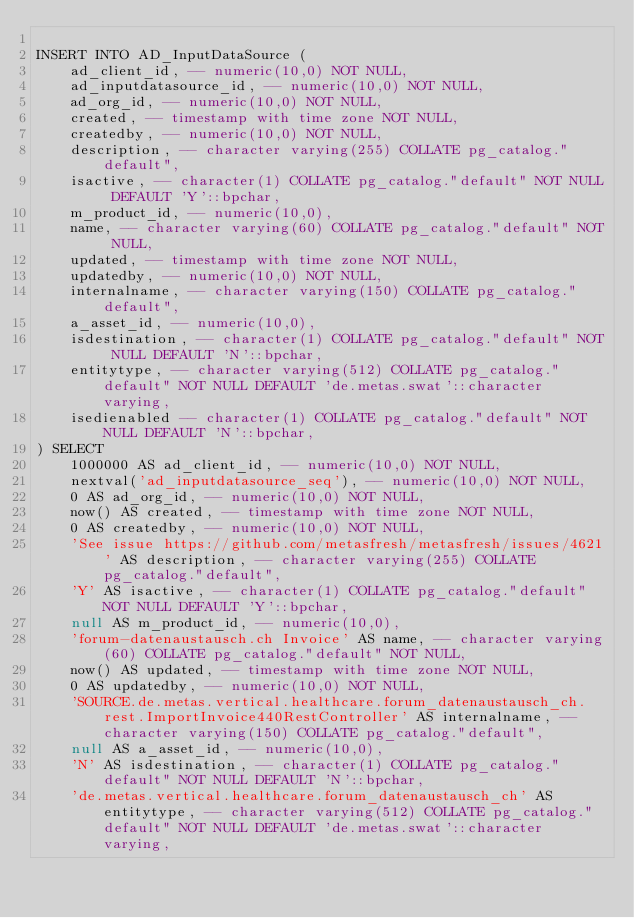Convert code to text. <code><loc_0><loc_0><loc_500><loc_500><_SQL_>
INSERT INTO AD_InputDataSource (
    ad_client_id, -- numeric(10,0) NOT NULL,
    ad_inputdatasource_id, -- numeric(10,0) NOT NULL,
    ad_org_id, -- numeric(10,0) NOT NULL,
    created, -- timestamp with time zone NOT NULL,
    createdby, -- numeric(10,0) NOT NULL,
    description, -- character varying(255) COLLATE pg_catalog."default",
    isactive, -- character(1) COLLATE pg_catalog."default" NOT NULL DEFAULT 'Y'::bpchar,
    m_product_id, -- numeric(10,0),
    name, -- character varying(60) COLLATE pg_catalog."default" NOT NULL,
    updated, -- timestamp with time zone NOT NULL,
    updatedby, -- numeric(10,0) NOT NULL,
    internalname, -- character varying(150) COLLATE pg_catalog."default",
    a_asset_id, -- numeric(10,0),
    isdestination, -- character(1) COLLATE pg_catalog."default" NOT NULL DEFAULT 'N'::bpchar,
    entitytype, -- character varying(512) COLLATE pg_catalog."default" NOT NULL DEFAULT 'de.metas.swat'::character varying,
    isedienabled -- character(1) COLLATE pg_catalog."default" NOT NULL DEFAULT 'N'::bpchar,
) SELECT
    1000000 AS ad_client_id, -- numeric(10,0) NOT NULL,
    nextval('ad_inputdatasource_seq'), -- numeric(10,0) NOT NULL,
    0 AS ad_org_id, -- numeric(10,0) NOT NULL,
    now() AS created, -- timestamp with time zone NOT NULL,
    0 AS createdby, -- numeric(10,0) NOT NULL,
    'See issue https://github.com/metasfresh/metasfresh/issues/4621' AS description, -- character varying(255) COLLATE pg_catalog."default",
    'Y' AS isactive, -- character(1) COLLATE pg_catalog."default" NOT NULL DEFAULT 'Y'::bpchar,
    null AS m_product_id, -- numeric(10,0),
    'forum-datenaustausch.ch Invoice' AS name, -- character varying(60) COLLATE pg_catalog."default" NOT NULL,
    now() AS updated, -- timestamp with time zone NOT NULL,
    0 AS updatedby, -- numeric(10,0) NOT NULL,
    'SOURCE.de.metas.vertical.healthcare.forum_datenaustausch_ch.rest.ImportInvoice440RestController' AS internalname, -- character varying(150) COLLATE pg_catalog."default",
    null AS a_asset_id, -- numeric(10,0),
    'N' AS isdestination, -- character(1) COLLATE pg_catalog."default" NOT NULL DEFAULT 'N'::bpchar,
    'de.metas.vertical.healthcare.forum_datenaustausch_ch' AS entitytype, -- character varying(512) COLLATE pg_catalog."default" NOT NULL DEFAULT 'de.metas.swat'::character varying,</code> 